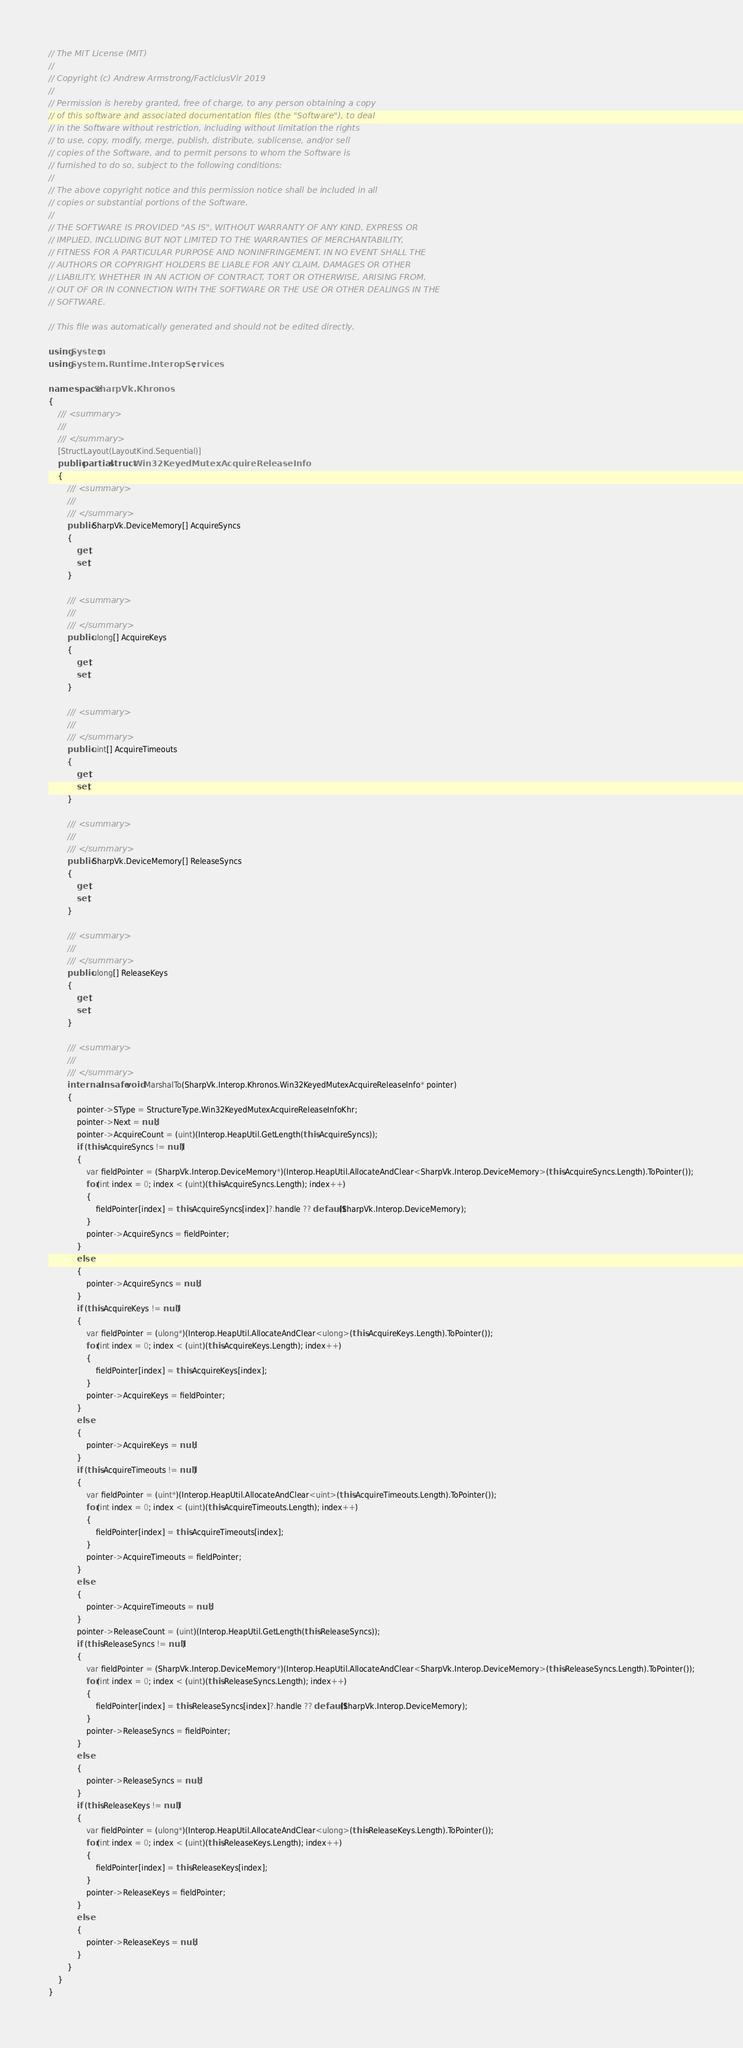<code> <loc_0><loc_0><loc_500><loc_500><_C#_>// The MIT License (MIT)
// 
// Copyright (c) Andrew Armstrong/FacticiusVir 2019
// 
// Permission is hereby granted, free of charge, to any person obtaining a copy
// of this software and associated documentation files (the "Software"), to deal
// in the Software without restriction, including without limitation the rights
// to use, copy, modify, merge, publish, distribute, sublicense, and/or sell
// copies of the Software, and to permit persons to whom the Software is
// furnished to do so, subject to the following conditions:
// 
// The above copyright notice and this permission notice shall be included in all
// copies or substantial portions of the Software.
// 
// THE SOFTWARE IS PROVIDED "AS IS", WITHOUT WARRANTY OF ANY KIND, EXPRESS OR
// IMPLIED, INCLUDING BUT NOT LIMITED TO THE WARRANTIES OF MERCHANTABILITY,
// FITNESS FOR A PARTICULAR PURPOSE AND NONINFRINGEMENT. IN NO EVENT SHALL THE
// AUTHORS OR COPYRIGHT HOLDERS BE LIABLE FOR ANY CLAIM, DAMAGES OR OTHER
// LIABILITY, WHETHER IN AN ACTION OF CONTRACT, TORT OR OTHERWISE, ARISING FROM,
// OUT OF OR IN CONNECTION WITH THE SOFTWARE OR THE USE OR OTHER DEALINGS IN THE
// SOFTWARE.

// This file was automatically generated and should not be edited directly.

using System;
using System.Runtime.InteropServices;

namespace SharpVk.Khronos
{
    /// <summary>
    /// 
    /// </summary>
    [StructLayout(LayoutKind.Sequential)]
    public partial struct Win32KeyedMutexAcquireReleaseInfo
    {
        /// <summary>
        /// 
        /// </summary>
        public SharpVk.DeviceMemory[] AcquireSyncs
        {
            get;
            set;
        }
        
        /// <summary>
        /// 
        /// </summary>
        public ulong[] AcquireKeys
        {
            get;
            set;
        }
        
        /// <summary>
        /// 
        /// </summary>
        public uint[] AcquireTimeouts
        {
            get;
            set;
        }
        
        /// <summary>
        /// 
        /// </summary>
        public SharpVk.DeviceMemory[] ReleaseSyncs
        {
            get;
            set;
        }
        
        /// <summary>
        /// 
        /// </summary>
        public ulong[] ReleaseKeys
        {
            get;
            set;
        }
        
        /// <summary>
        /// 
        /// </summary>
        internal unsafe void MarshalTo(SharpVk.Interop.Khronos.Win32KeyedMutexAcquireReleaseInfo* pointer)
        {
            pointer->SType = StructureType.Win32KeyedMutexAcquireReleaseInfoKhr;
            pointer->Next = null;
            pointer->AcquireCount = (uint)(Interop.HeapUtil.GetLength(this.AcquireSyncs));
            if (this.AcquireSyncs != null)
            {
                var fieldPointer = (SharpVk.Interop.DeviceMemory*)(Interop.HeapUtil.AllocateAndClear<SharpVk.Interop.DeviceMemory>(this.AcquireSyncs.Length).ToPointer());
                for(int index = 0; index < (uint)(this.AcquireSyncs.Length); index++)
                {
                    fieldPointer[index] = this.AcquireSyncs[index]?.handle ?? default(SharpVk.Interop.DeviceMemory);
                }
                pointer->AcquireSyncs = fieldPointer;
            }
            else
            {
                pointer->AcquireSyncs = null;
            }
            if (this.AcquireKeys != null)
            {
                var fieldPointer = (ulong*)(Interop.HeapUtil.AllocateAndClear<ulong>(this.AcquireKeys.Length).ToPointer());
                for(int index = 0; index < (uint)(this.AcquireKeys.Length); index++)
                {
                    fieldPointer[index] = this.AcquireKeys[index];
                }
                pointer->AcquireKeys = fieldPointer;
            }
            else
            {
                pointer->AcquireKeys = null;
            }
            if (this.AcquireTimeouts != null)
            {
                var fieldPointer = (uint*)(Interop.HeapUtil.AllocateAndClear<uint>(this.AcquireTimeouts.Length).ToPointer());
                for(int index = 0; index < (uint)(this.AcquireTimeouts.Length); index++)
                {
                    fieldPointer[index] = this.AcquireTimeouts[index];
                }
                pointer->AcquireTimeouts = fieldPointer;
            }
            else
            {
                pointer->AcquireTimeouts = null;
            }
            pointer->ReleaseCount = (uint)(Interop.HeapUtil.GetLength(this.ReleaseSyncs));
            if (this.ReleaseSyncs != null)
            {
                var fieldPointer = (SharpVk.Interop.DeviceMemory*)(Interop.HeapUtil.AllocateAndClear<SharpVk.Interop.DeviceMemory>(this.ReleaseSyncs.Length).ToPointer());
                for(int index = 0; index < (uint)(this.ReleaseSyncs.Length); index++)
                {
                    fieldPointer[index] = this.ReleaseSyncs[index]?.handle ?? default(SharpVk.Interop.DeviceMemory);
                }
                pointer->ReleaseSyncs = fieldPointer;
            }
            else
            {
                pointer->ReleaseSyncs = null;
            }
            if (this.ReleaseKeys != null)
            {
                var fieldPointer = (ulong*)(Interop.HeapUtil.AllocateAndClear<ulong>(this.ReleaseKeys.Length).ToPointer());
                for(int index = 0; index < (uint)(this.ReleaseKeys.Length); index++)
                {
                    fieldPointer[index] = this.ReleaseKeys[index];
                }
                pointer->ReleaseKeys = fieldPointer;
            }
            else
            {
                pointer->ReleaseKeys = null;
            }
        }
    }
}
</code> 